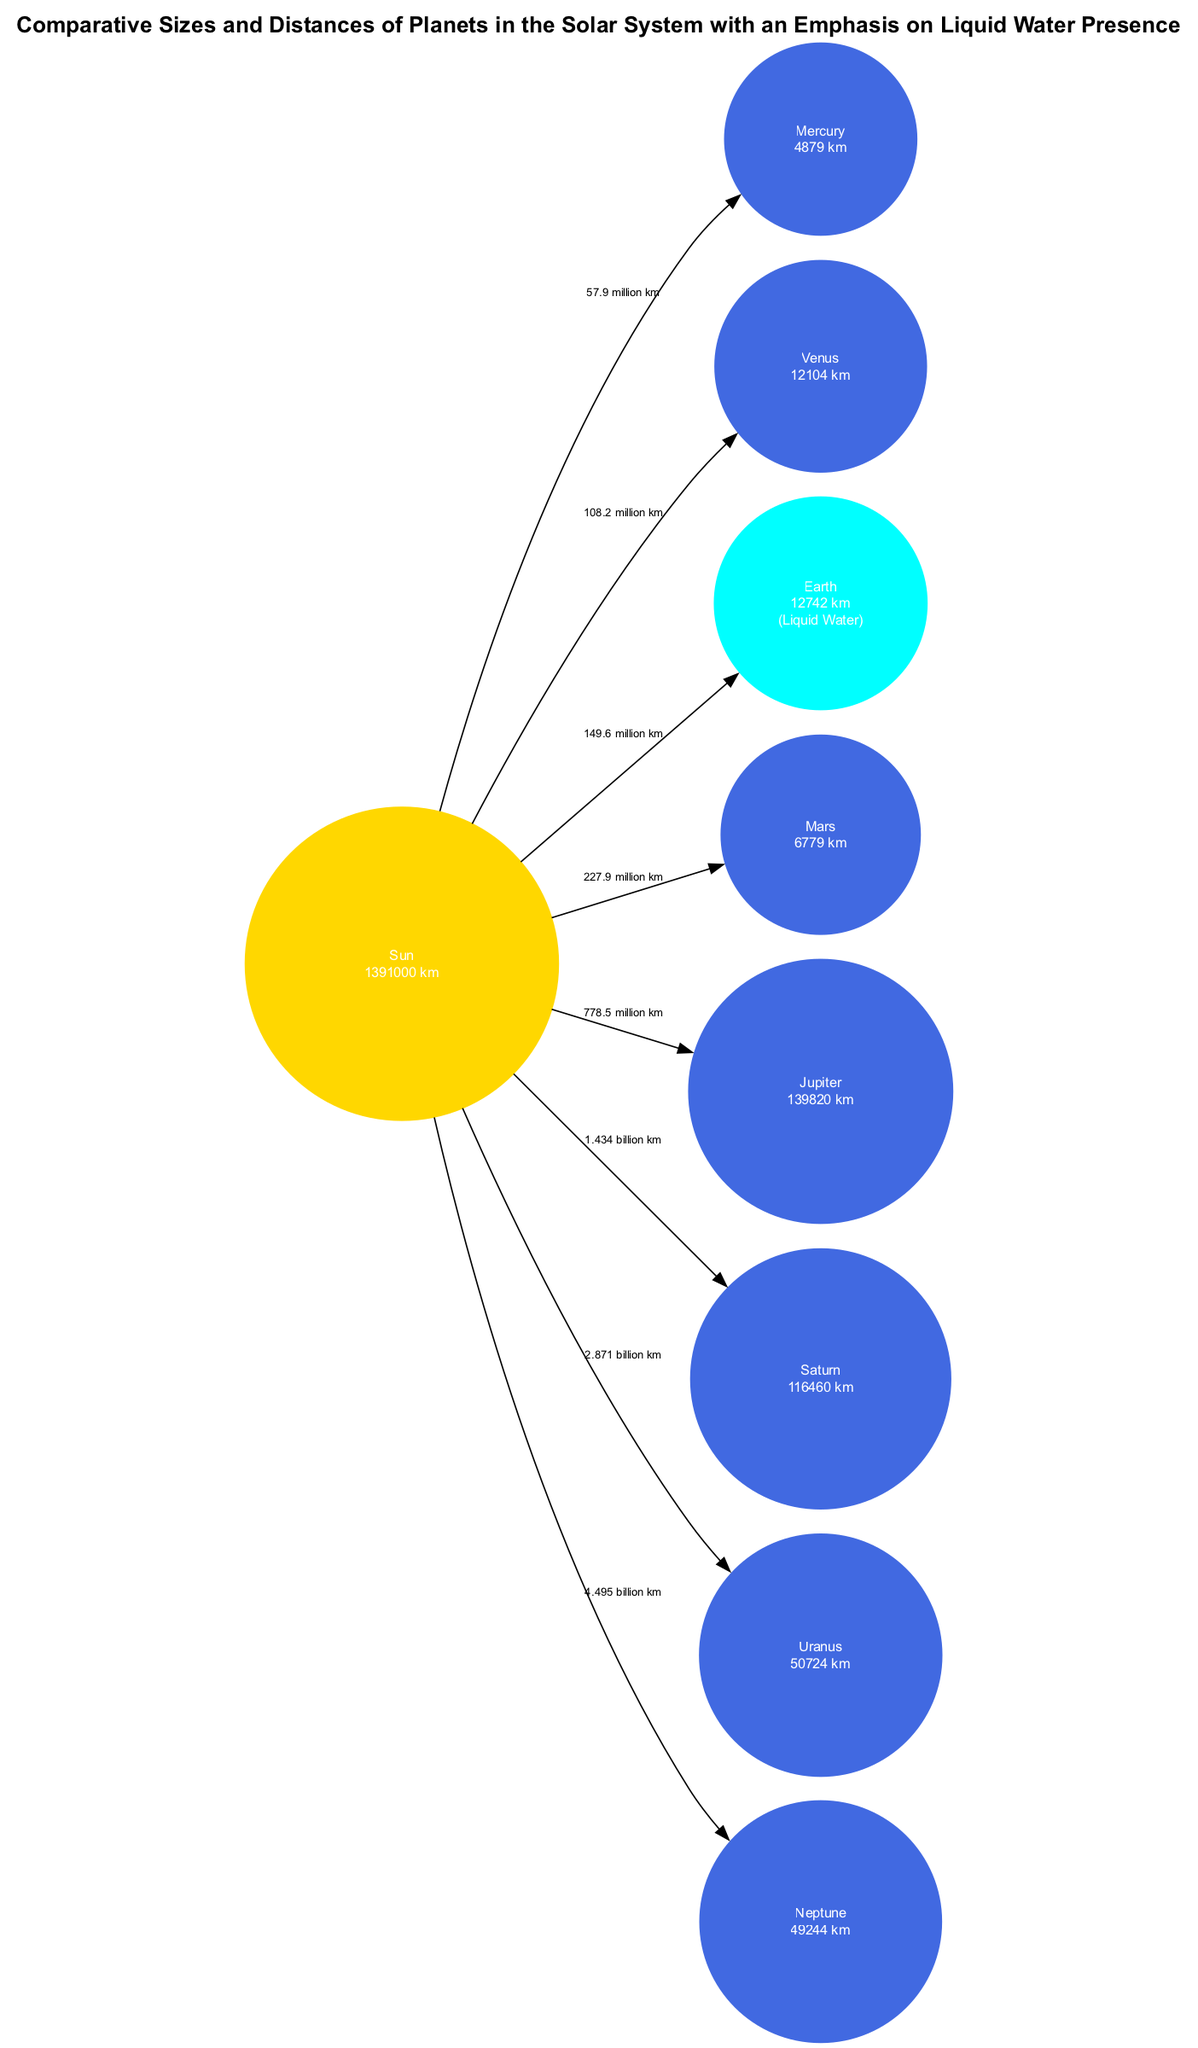What is the distance from the Sun to Earth? The diagram shows that the edge from the Sun to Earth is labeled with the distance "149.6 million km." Therefore, the distance from the Sun to Earth is directly provided on the edge.
Answer: 149.6 million km Which planet has liquid water? From the nodes in the diagram, only Earth is noted to have "Liquid Water" in its attributes. By checking all nodes, I find that only Earth specifies this feature, making the answer straightforward.
Answer: Earth What is the size of Jupiter? The diagram's node for Jupiter indicates a size of "139820 km." This information is explicitly stated on the node itself.
Answer: 139820 km How many planets are shown in the diagram? To find the number of planets, I count the nodes labeled as planets. There are eight nodes (Mercury, Venus, Earth, Mars, Jupiter, Saturn, Uranus, and Neptune), as they represent each planet in the solar system.
Answer: 8 Which planet is farthest from the Sun? By inspecting the distances provided, Neptune is at "4.495 billion km," which is greater than all the other planets’ distances from the Sun. Therefore, it is the farthest.
Answer: Neptune How much larger is Earth than Mercury? The sizes of these planets from the diagram are given as "12742 km" for Earth and "4879 km" for Mercury. To find the difference, I subtract 4879 from 12742, yielding a difference of 7853 km, indicating how much larger Earth is compared to Mercury.
Answer: 7853 km What type of celestial body is Saturn? Looking at the node details for Saturn, it is labeled as a "planet." Thus, the type of celestial body Saturn is identified clearly in the diagram.
Answer: Planet What is the distance from Mars to the Sun? The edge between the Sun and Mars shows that the distance is labeled "227.9 million km." By reading the diagram, I find this value clearly stated alongside the edge.
Answer: 227.9 million km Which two planets are closest to each other based on their distances from the Sun? When comparing the distances from the Sun, Mercury (57.9 million km) and Venus (108.2 million km) have the smallest difference (50.3 million km), showing they are the closest to each other among the planets listed.
Answer: Mercury and Venus 